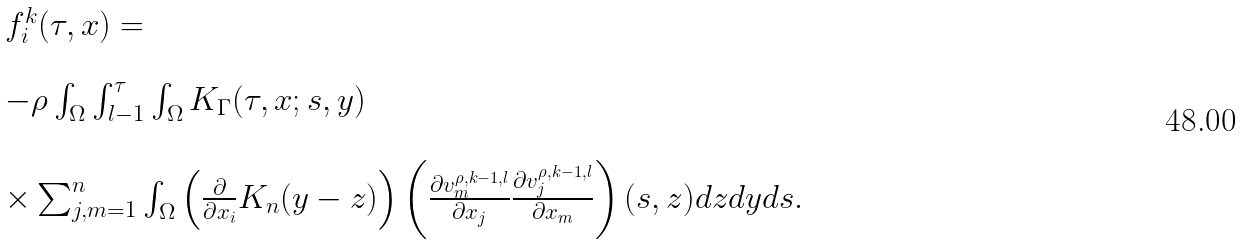Convert formula to latex. <formula><loc_0><loc_0><loc_500><loc_500>\begin{array} { l l } f ^ { k } _ { i } ( \tau , x ) = \\ \\ - \rho \int _ { \Omega } \int _ { l - 1 } ^ { \tau } \int _ { \Omega } K _ { \Gamma } ( \tau , x ; s , y ) \\ \\ \times \sum _ { j , m = 1 } ^ { n } \int _ { \Omega } \left ( \frac { \partial } { \partial x _ { i } } K _ { n } ( y - z ) \right ) \left ( \frac { \partial v ^ { \rho , k - 1 , l } _ { m } } { \partial x _ { j } } \frac { \partial v ^ { \rho , k - 1 , l } _ { j } } { \partial x _ { m } } \right ) ( s , z ) d z d y d s . \end{array}</formula> 